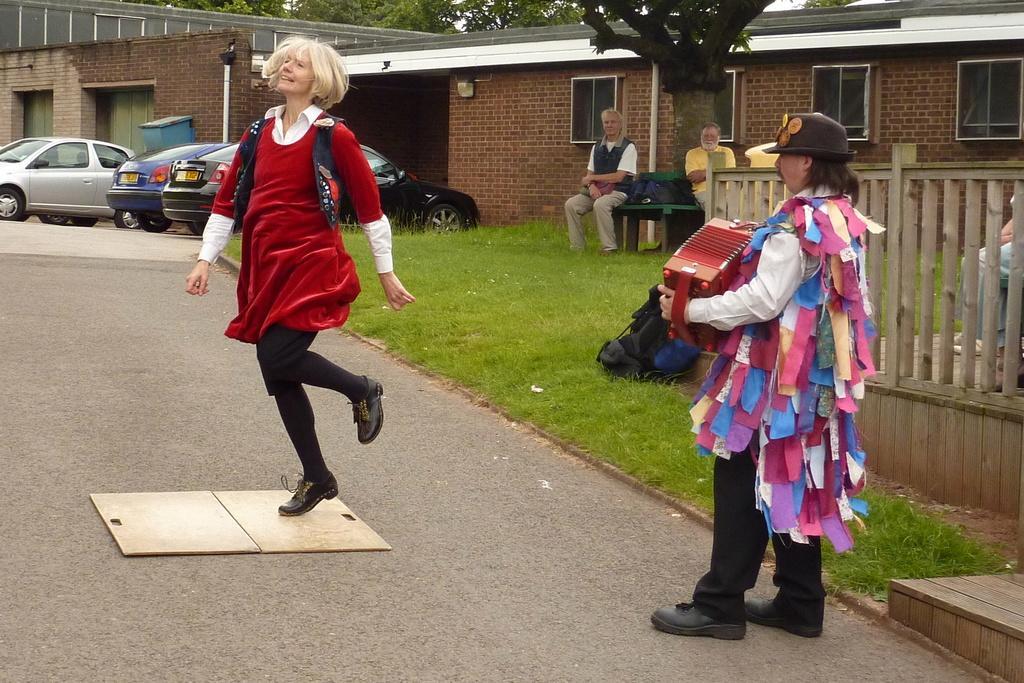Describe this image in one or two sentences. In this picture there is a woman wearing a red color dress and a man, holding a musical instrument in his hand. The man is wearing cap on his head. Beside him there is a wooden railing and a bag placed on the ground. There are two men sitting on the bench, under the tree. In the background there are some cars parked here and we can observe a house. 